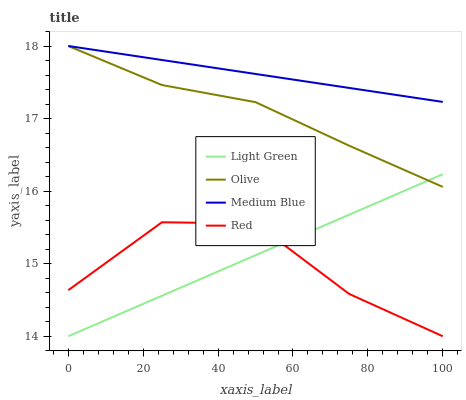Does Red have the minimum area under the curve?
Answer yes or no. Yes. Does Medium Blue have the maximum area under the curve?
Answer yes or no. Yes. Does Medium Blue have the minimum area under the curve?
Answer yes or no. No. Does Red have the maximum area under the curve?
Answer yes or no. No. Is Light Green the smoothest?
Answer yes or no. Yes. Is Red the roughest?
Answer yes or no. Yes. Is Medium Blue the smoothest?
Answer yes or no. No. Is Medium Blue the roughest?
Answer yes or no. No. Does Red have the lowest value?
Answer yes or no. Yes. Does Medium Blue have the lowest value?
Answer yes or no. No. Does Medium Blue have the highest value?
Answer yes or no. Yes. Does Red have the highest value?
Answer yes or no. No. Is Red less than Olive?
Answer yes or no. Yes. Is Medium Blue greater than Light Green?
Answer yes or no. Yes. Does Olive intersect Light Green?
Answer yes or no. Yes. Is Olive less than Light Green?
Answer yes or no. No. Is Olive greater than Light Green?
Answer yes or no. No. Does Red intersect Olive?
Answer yes or no. No. 